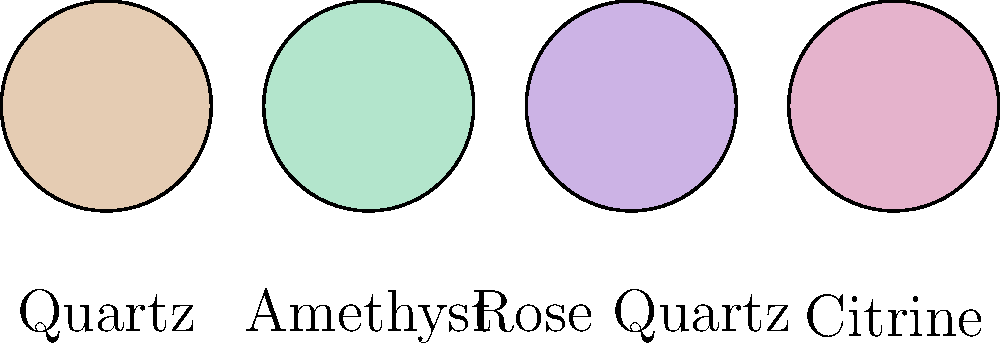As a spiritual life coach, you're developing a machine learning model to categorize healing crystals from photographs. Which feature would be most crucial for distinguishing between the crystals shown in the image? To answer this question, let's analyze the key distinguishing features of the crystals shown:

1. Shape: All crystals are depicted as circular, so shape is not a distinguishing factor.

2. Size: All crystals appear to be the same size, so this is not a distinguishing feature.

3. Color: This is the most prominent difference between the crystals shown:
   - Quartz: Light beige
   - Amethyst: Purple
   - Rose Quartz: Pink
   - Citrine: Yellow

4. Texture: The image doesn't show detailed texture, so this isn't a distinguishing feature here.

5. Transparency: The image doesn't depict transparency, so this isn't a factor.

Given these observations, the most crucial feature for distinguishing between these crystals in photographs would be color. A machine learning model could use color analysis to categorize these crystals effectively.

In more advanced models, other features like crystal structure, transparency, or inclusions might also be important, but based solely on the information provided in this image, color is the key distinguishing feature.
Answer: Color 